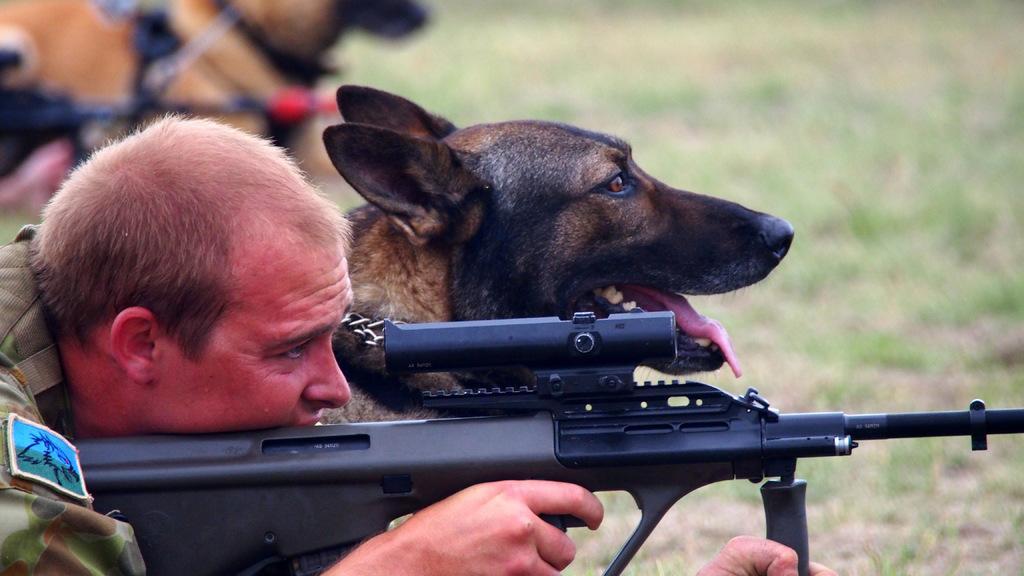Can you describe this image briefly? This picture shows about army soldier lying on the ground with black color gun trying to shoot the target. Beside you can see a brown and black German shepherd dog sitting on the ground. 